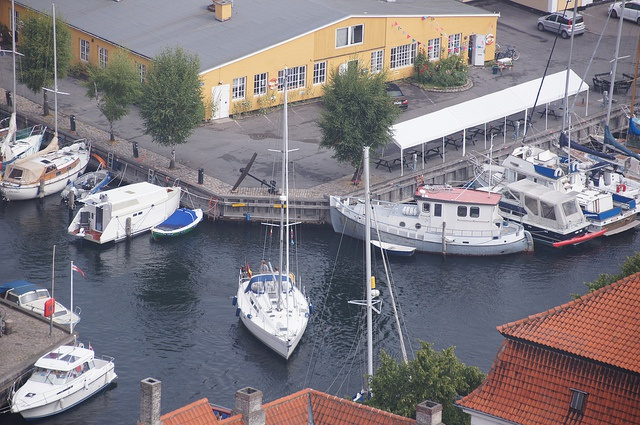Describe the objects in this image and their specific colors. I can see boat in maroon, lightgray, darkgray, and gray tones, boat in maroon, lightgray, darkgray, and gray tones, boat in maroon, lightgray, darkgray, gray, and blue tones, boat in maroon, lightgray, darkgray, and gray tones, and boat in maroon, white, darkgray, and gray tones in this image. 